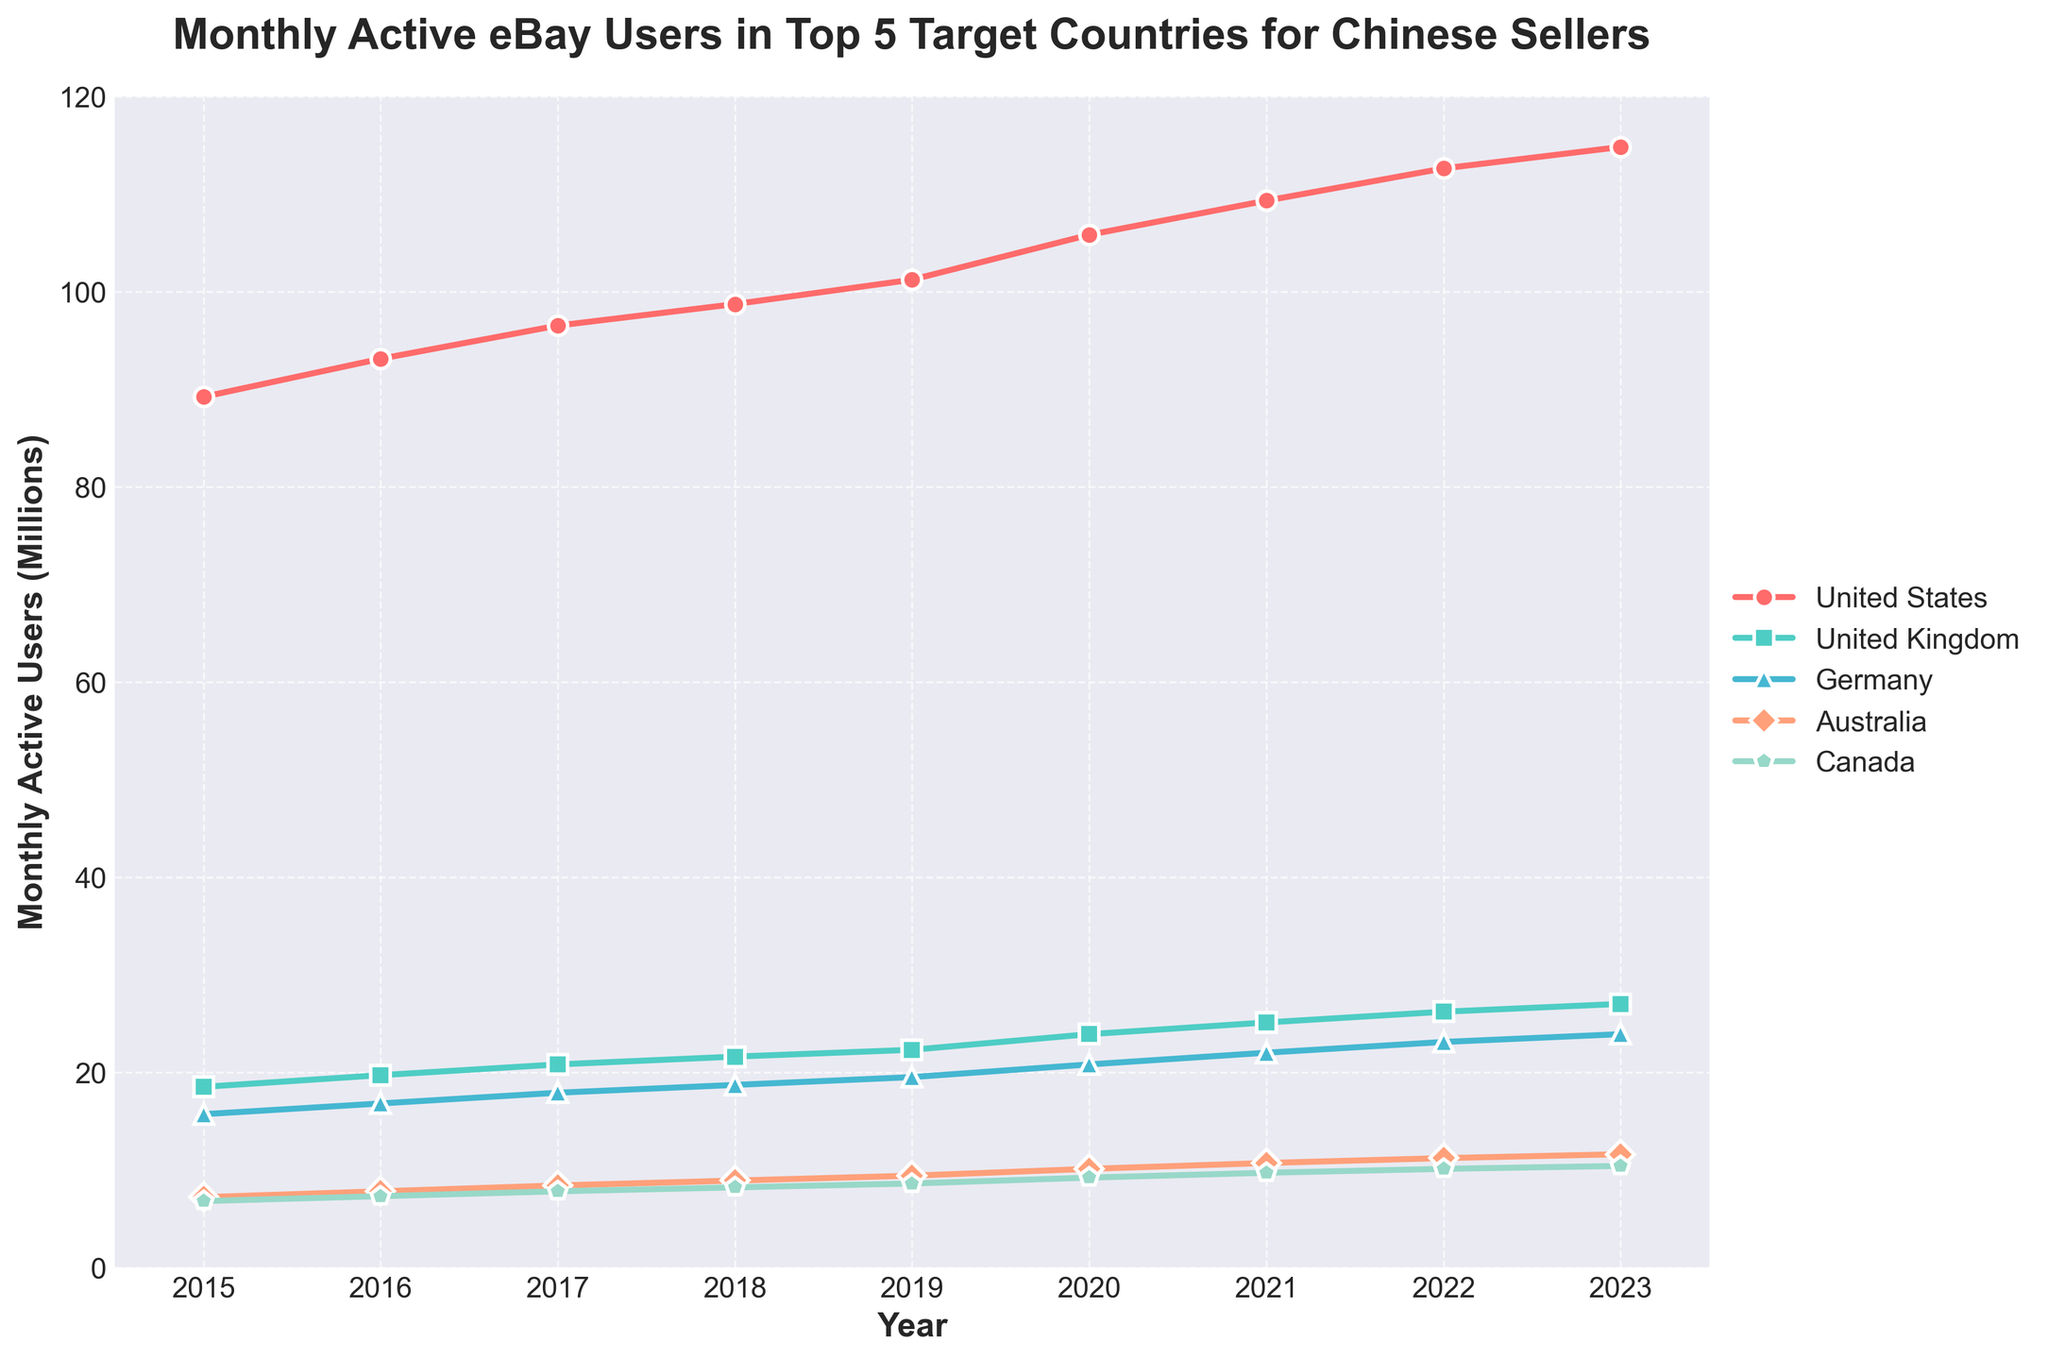How many millions of monthly active users did ebBay have in the United States in 2017? Identify the line for the United States, follow it to the year 2017, and read the value from the Y-axis.
Answer: 96.5 Which country had the smallest increase in monthly active users from 2015 to 2023? Calculate the difference in monthly active users for each country from 2015 to 2023 and compare them. United States: 114.8-89.2, United Kingdom: 27.0-18.5, Germany: 23.9-15.7, Australia: 11.6-7.2, Canada: 10.4-6.8. The smallest increase is for Canada, 10.4-6.8 = 3.6.
Answer: Canada What's the median number of monthly active eBay users in Australia over the years? Organize the data points for Australia: 7.2, 7.8, 8.4, 8.9, 9.4, 10.1, 10.7, 11.2, 11.6. Since there is an odd number of data points (9), the median is the middle value in the sorted list.
Answer: 8.9 Which country had the most stable number of monthly active users over the years? Calculate the range (difference between maximum and minimum values) for each country over the years and identify the smallest range. United States: 114.8-89.2, United Kingdom: 27.0-18.5, Germany: 23.9-15.7, Australia: 11.6-7.2, Canada: 10.4-6.8. The most stable is Germany with a range of 23.9-15.7 = 8.2.
Answer: Germany In which year did the United Kingdom surpass 20 million monthly active users? Follow the line for the United Kingdom and identify the year where the value exceeds 20 million users for the first time, indicated by the position on the Y-axis.
Answer: 2017 Compare the trend of monthly active users between Germany and Australia from 2015 to 2023. Which country saw a more significant relative increase? Calculate the relative increase by finding the percentage increase from 2015 to 2023 for Germany and Australia. Germany: (23.9-15.7)/15.7 * 100, Australia: (11.6-7.2)/7.2 * 100. Compare the two percentages.
Answer: Germany: (23.9-15.7)/15.7 * 100 ≈ 52.2%, Australia: (11.6-7.2)/7.2 * 100 ≈ 61.1%. Australia had a more significant relative increase What visual attribute represents the United States in the plot? Identify the visual attributes (color, marker style) used to represent the United States in the line chart.
Answer: Red line with circle markers 